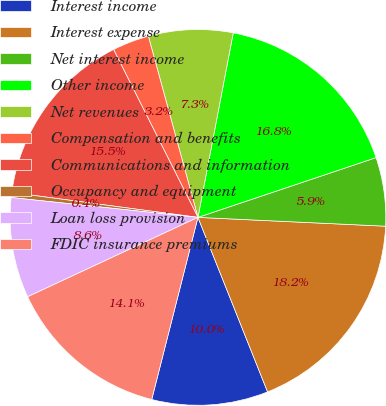Convert chart to OTSL. <chart><loc_0><loc_0><loc_500><loc_500><pie_chart><fcel>Interest income<fcel>Interest expense<fcel>Net interest income<fcel>Other income<fcel>Net revenues<fcel>Compensation and benefits<fcel>Communications and information<fcel>Occupancy and equipment<fcel>Loan loss provision<fcel>FDIC insurance premiums<nl><fcel>10.0%<fcel>18.21%<fcel>5.9%<fcel>16.84%<fcel>7.26%<fcel>3.16%<fcel>15.47%<fcel>0.43%<fcel>8.63%<fcel>14.1%<nl></chart> 